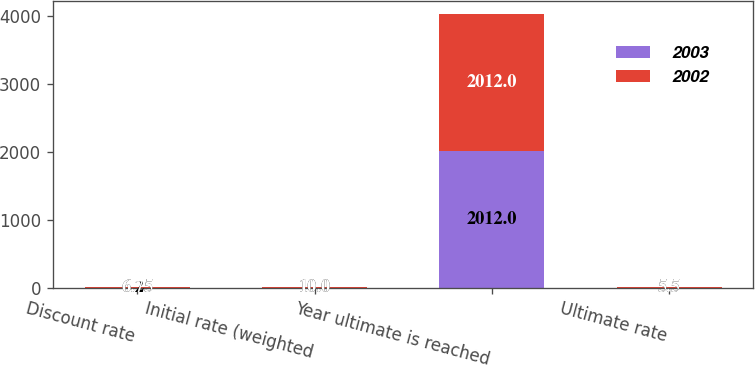<chart> <loc_0><loc_0><loc_500><loc_500><stacked_bar_chart><ecel><fcel>Discount rate<fcel>Initial rate (weighted<fcel>Year ultimate is reached<fcel>Ultimate rate<nl><fcel>2003<fcel>6.25<fcel>10<fcel>2012<fcel>5.5<nl><fcel>2002<fcel>6.75<fcel>10<fcel>2012<fcel>5.5<nl></chart> 